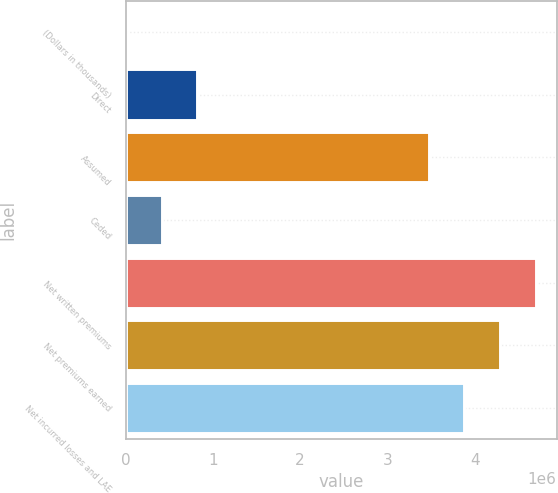<chart> <loc_0><loc_0><loc_500><loc_500><bar_chart><fcel>(Dollars in thousands)<fcel>Direct<fcel>Assumed<fcel>Ceded<fcel>Net written premiums<fcel>Net premiums earned<fcel>Net incurred losses and LAE<nl><fcel>2011<fcel>823389<fcel>3.47109e+06<fcel>412700<fcel>4.70315e+06<fcel>4.29246e+06<fcel>3.88178e+06<nl></chart> 